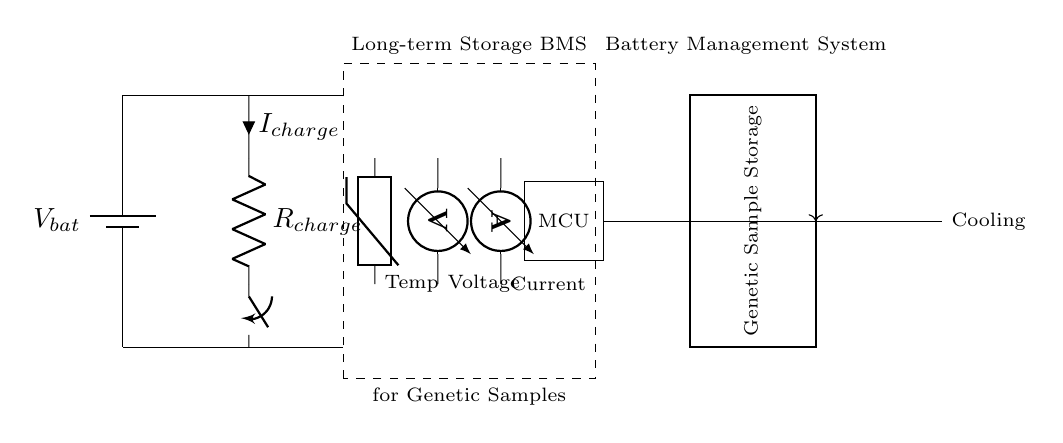What is the main purpose of the battery management system? The battery management system is designed to ensure the safe and efficient charging of the battery while monitoring various parameters.
Answer: safe and efficient charging What type of sensor is used to monitor temperature? The circuit includes a thermistor to measure the temperature of the system.
Answer: thermistor What component controls the charging current? The charging current is controlled by the resistor labeled R charge, which limits the amount of current flowing into the battery.
Answer: R charge What does MCU stand for in this circuit? MCU stands for microcontroller which manages the operations of the battery management system and can implement logic based on sensor inputs.
Answer: microcontroller How does the cooling system operate in relation to the genetic sample storage? The cooling system is connected to the genetic sample storage to maintain an optimal temperature, controlling its operation via the microcontroller.
Answer: maintains optimal temperature What type of power switch is used in the circuit? The circuit utilizes a switch which can open or close the circuit to allow or stop the flow of current to the battery.
Answer: switch What is the role of the voltage sensor? The voltage sensor measures the voltage level across the battery to ensure it is operating within the required limits.
Answer: measure voltage level 